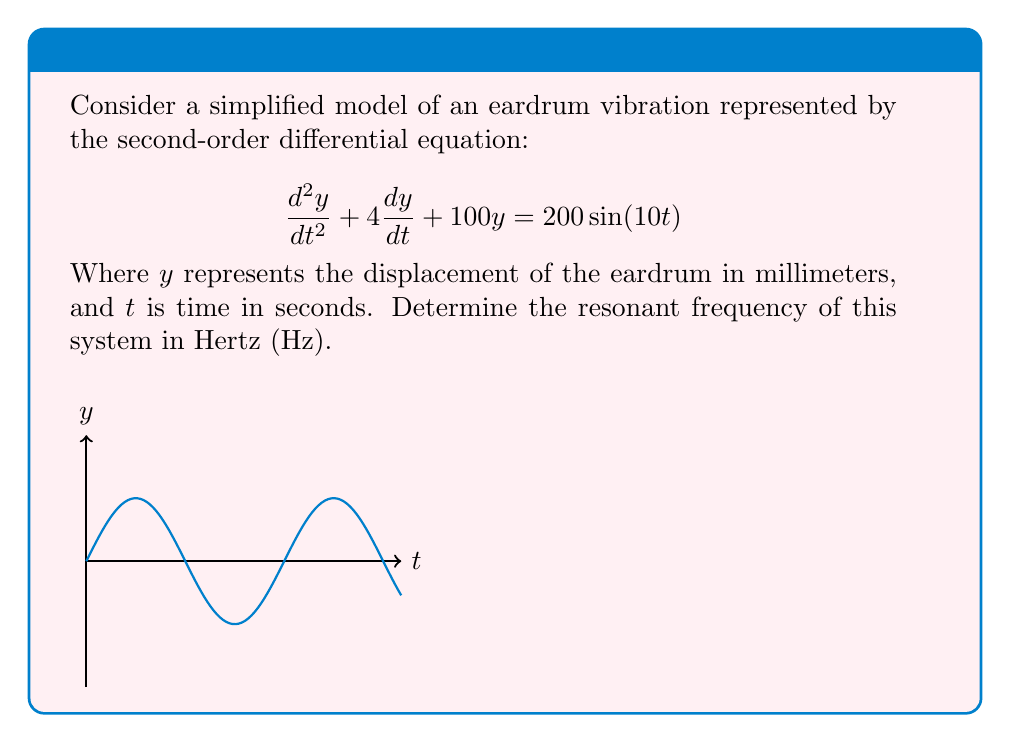Can you answer this question? To find the resonant frequency, we need to follow these steps:

1) The general form of a second-order differential equation is:

   $$\frac{d^2y}{dt^2} + 2\zeta\omega_n\frac{dy}{dt} + \omega_n^2y = F(t)$$

   Where $\zeta$ is the damping ratio and $\omega_n$ is the natural frequency.

2) Comparing our equation to the general form:

   $$\frac{d^2y}{dt^2} + 4\frac{dy}{dt} + 100y = 200\sin(10t)$$

   We can see that $2\zeta\omega_n = 4$ and $\omega_n^2 = 100$.

3) From $\omega_n^2 = 100$, we can find $\omega_n$:

   $$\omega_n = \sqrt{100} = 10 \text{ rad/s}$$

4) The resonant frequency $\omega_r$ is related to the natural frequency $\omega_n$ by:

   $$\omega_r = \omega_n\sqrt{1-2\zeta^2}$$

5) To find $\zeta$, we use $2\zeta\omega_n = 4$:

   $$2\zeta(10) = 4$$
   $$\zeta = 0.2$$

6) Now we can calculate $\omega_r$:

   $$\omega_r = 10\sqrt{1-2(0.2)^2} = 10\sqrt{0.92} \approx 9.59 \text{ rad/s}$$

7) To convert from rad/s to Hz, we divide by $2\pi$:

   $$f_r = \frac{\omega_r}{2\pi} \approx \frac{9.59}{2\pi} \approx 1.53 \text{ Hz}$$

Thus, the resonant frequency is approximately 1.53 Hz.
Answer: 1.53 Hz 